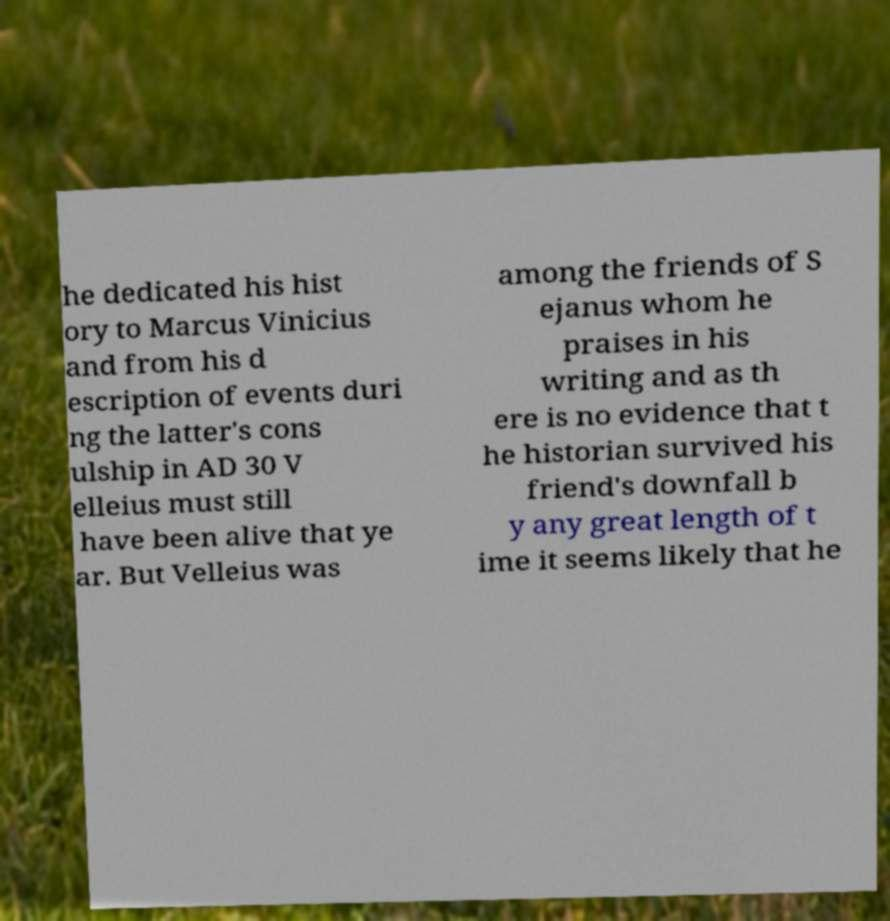Please read and relay the text visible in this image. What does it say? he dedicated his hist ory to Marcus Vinicius and from his d escription of events duri ng the latter's cons ulship in AD 30 V elleius must still have been alive that ye ar. But Velleius was among the friends of S ejanus whom he praises in his writing and as th ere is no evidence that t he historian survived his friend's downfall b y any great length of t ime it seems likely that he 